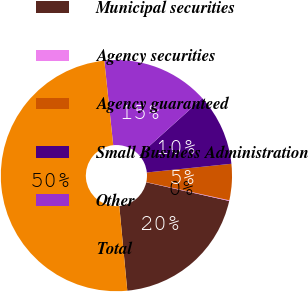<chart> <loc_0><loc_0><loc_500><loc_500><pie_chart><fcel>Municipal securities<fcel>Agency securities<fcel>Agency guaranteed<fcel>Small Business Administration<fcel>Other<fcel>Total<nl><fcel>19.98%<fcel>0.09%<fcel>5.06%<fcel>10.03%<fcel>15.01%<fcel>49.83%<nl></chart> 